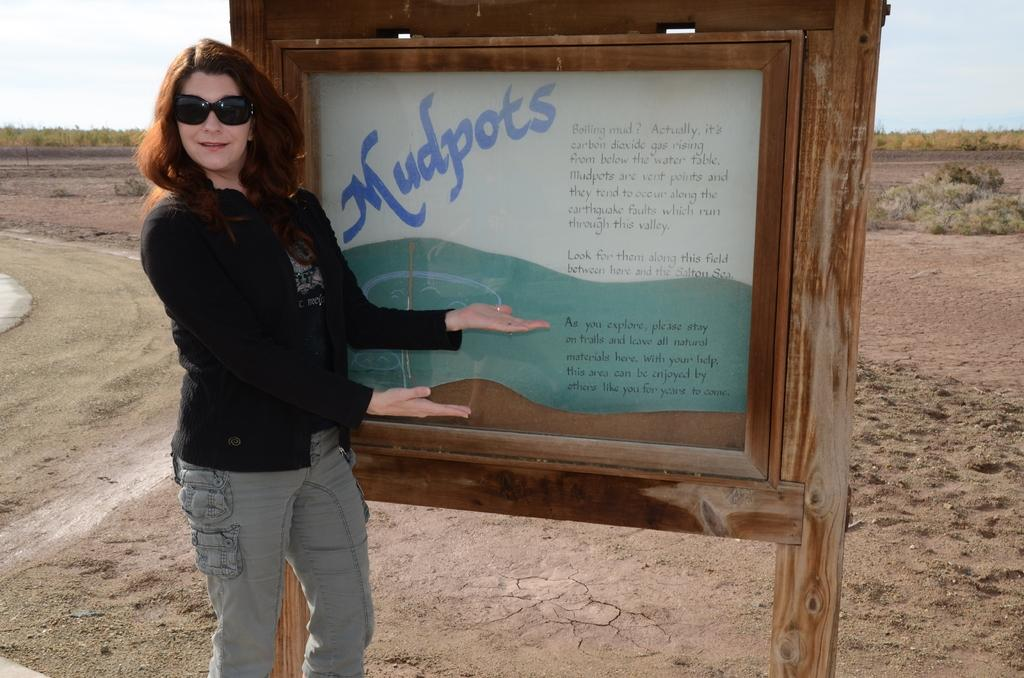Who is present in the image? There is a lady in the image. What is the lady wearing? The lady is wearing glasses. What can be seen on the board in the image? There is text on the board in the image. What type of natural environment is visible in the background? There are trees in the background of the image. What is visible at the bottom of the image? The ground is visible at the bottom of the image. Can you see any snow in the image? There is no snow present in the image. Is there a tiger stitching a pattern on the board in the image? There is no tiger or stitching activity present in the image. 